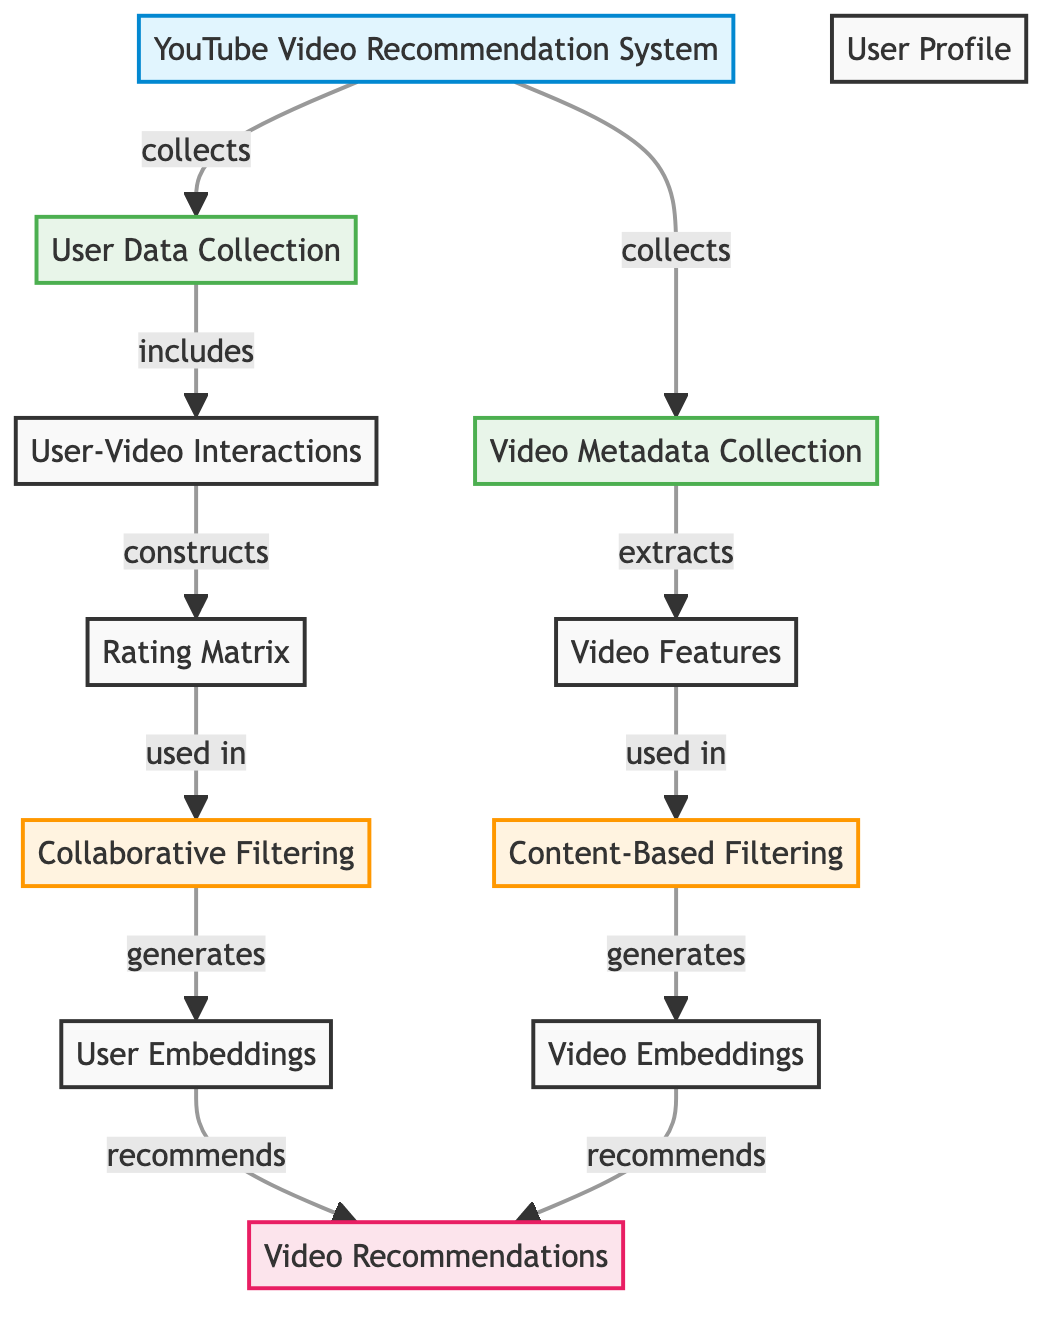What is the main system represented in the diagram? The diagram represents the "YouTube Video Recommendation System" as the main system displayed in the first node. This node is labeled clearly and central to the flow of the diagram.
Answer: YouTube Video Recommendation System How many collections are present in the diagram? Two collections are listed in the diagram, namely "User Data Collection" and "Video Metadata Collection," which are both shown as separate nodes.
Answer: 2 What do the user-video interactions construct? The user-video interactions are described to construct the "Rating Matrix," which is depicted as a node that follows from user-video interactions in the flow.
Answer: Rating Matrix What type of filtering techniques are used in this recommendation system? The diagram identifies two types of filtering techniques: "Collaborative Filtering" and "Content-Based Filtering," which are denoted in the filtering nodes connected to distinct paths.
Answer: Collaborative Filtering and Content-Based Filtering How are the user embeddings generated? User embeddings are generated from the "Collaborative Filtering"; hence, one must follow the connections from the main recommendation system to see that process explicitly.
Answer: Collaborative Filtering What connections exist between video features and content-based filtering? The connection between video features and content-based filtering is established by the "extracts" keyword, which links video features from video metadata to content-based filtering, indicating its use in this type of filtering.
Answer: used in Which node generates the video recommendations? Both "User Embeddings" and "Video Embeddings" nodes lead to the generation of "Video Recommendations," indicating that recommendations use outputs from both embeddings.
Answer: Video Recommendations What information do the nodes "User Profile" and "Video Features" provide? "User Profile" provides user-related data for collaborative filtering, while "Video Features" provides characteristics from metadata for content-based filtering, both serving distinct filtering techniques in the recommendation system.
Answer: User-related data and characteristics from metadata How many edges are there leading to the "Video Recommendations" node? There are two edges leading to the "Video Recommendations" node; one from "User Embeddings" and another from "Video Embeddings," as shown by the two connection arrows leading into this node.
Answer: 2 